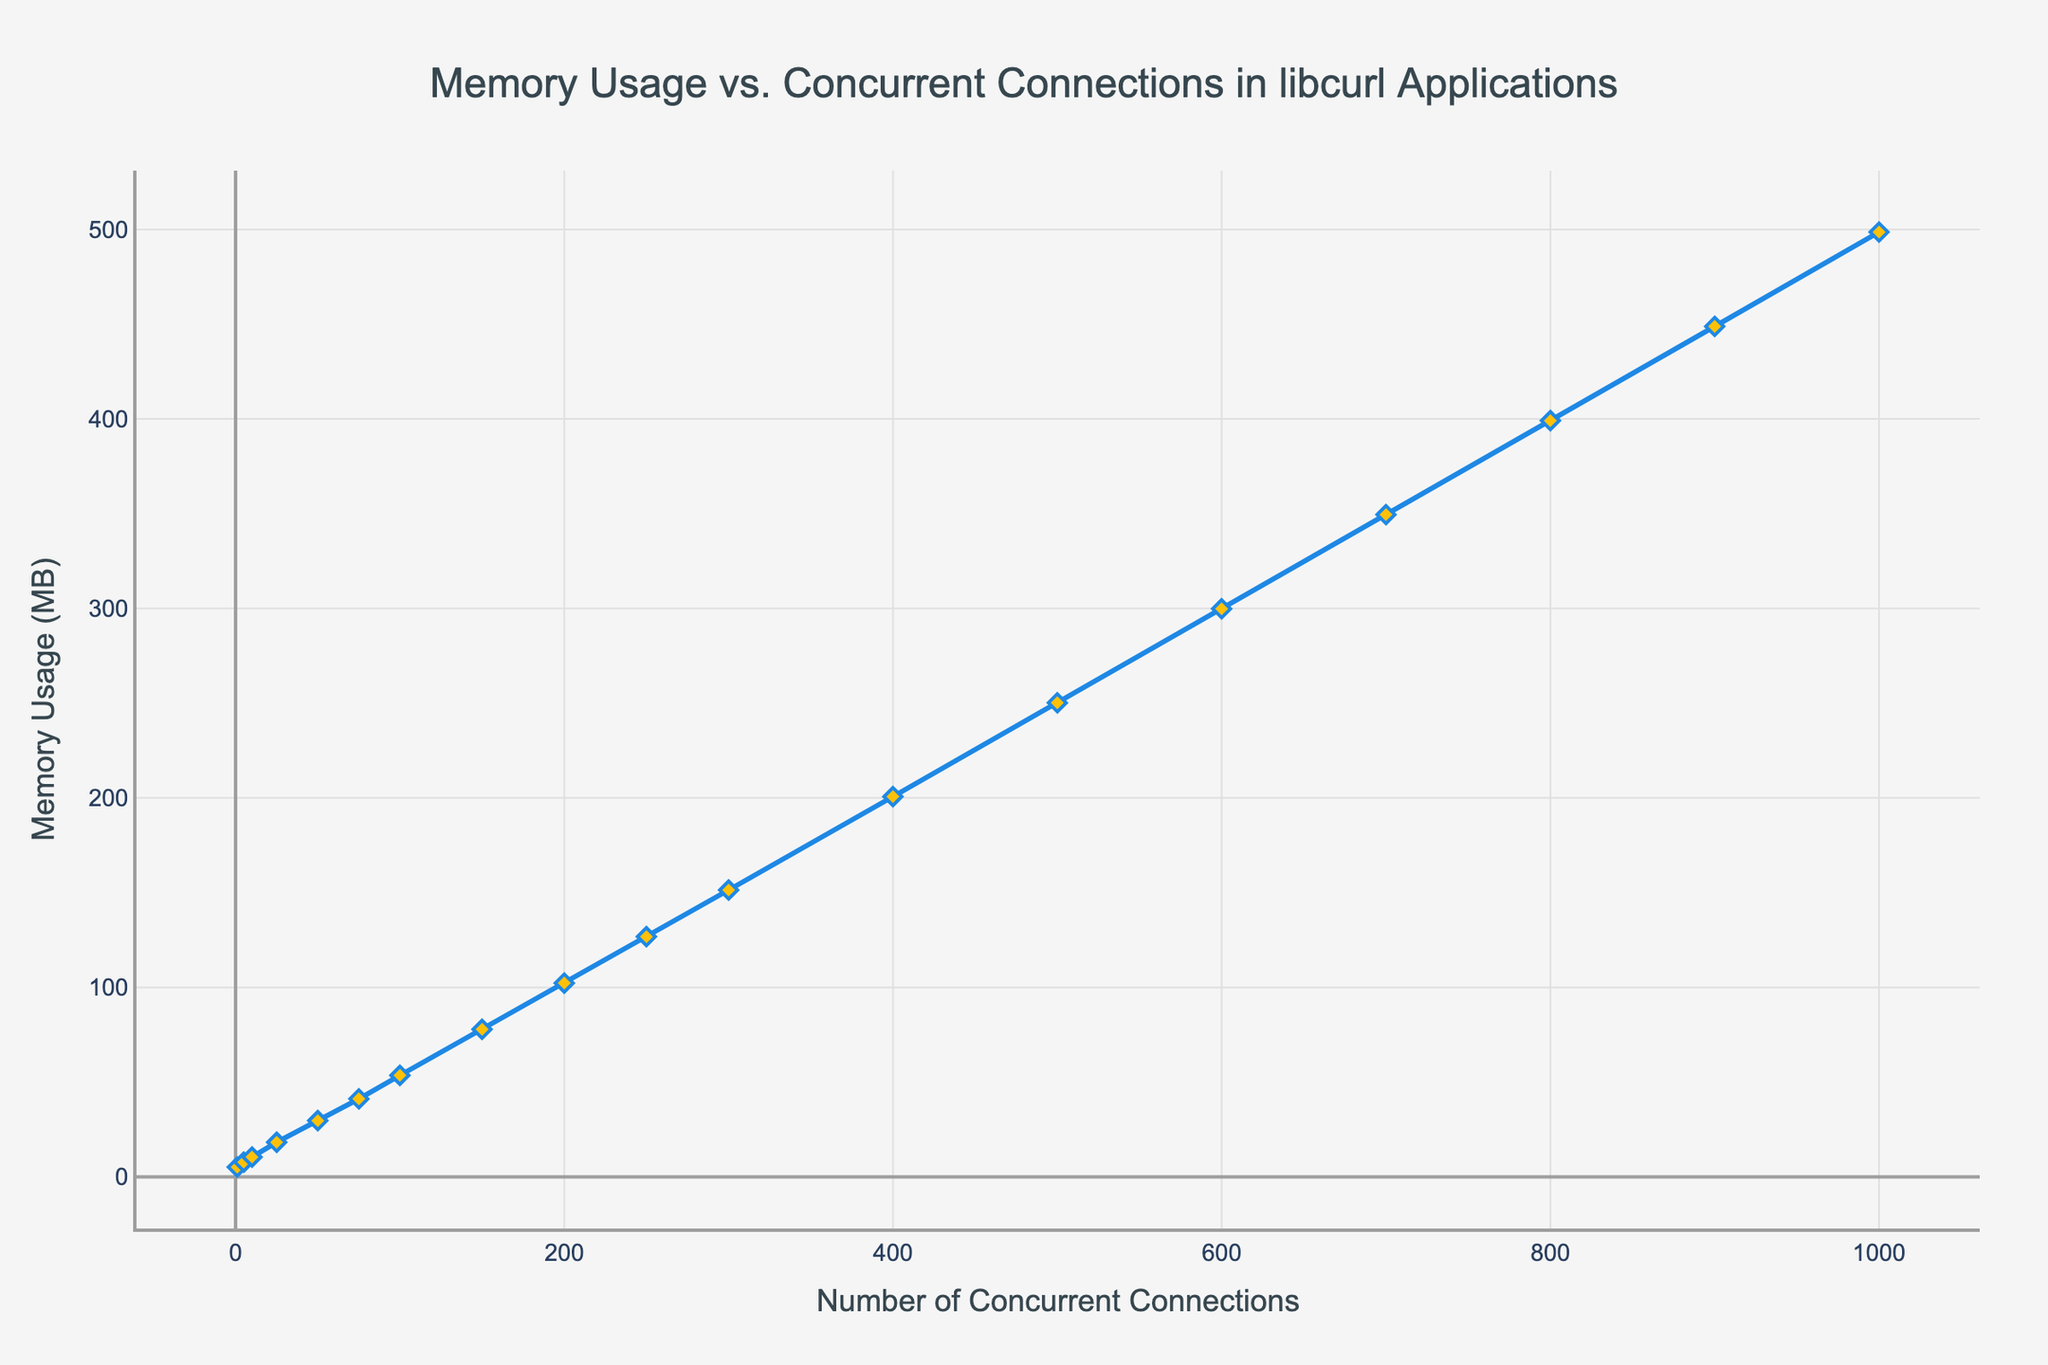What is the Memory Usage (MB) for 50 concurrent connections? Look for the data point where the number of concurrent connections is 50. The corresponding Memory Usage (MB) is easily readable from the y-axis.
Answer: 29.7 MB How much more memory is used at 200 connections compared to 100 connections? Subtract the Memory Usage (MB) at 100 connections from the Memory Usage (MB) at 200 connections. 102.3 MB - 53.6 MB = 48.7 MB.
Answer: 48.7 MB At which concurrent connections does the memory usage cross 100 MB? Find the data point where the Memory Usage (MB) first exceeds 100 MB. This occurs at 200 concurrent connections.
Answer: 200 connections What is the average Memory Usage (MB) for 1, 10, 100, and 1000 concurrent connections? Sum the Memory Usage (MB) values for the given connection counts and divide by the number of connection counts. (5.2 + 10.5 + 53.6 + 498.6)/4 = 567.9/4 = 141.975 MB.
Answer: 141.975 MB Which range of concurrent connections sees the fastest increase in memory usage? Compare the differences in Memory Usage (MB) across different ranges. The increase is steepest between 1 to 100 connections, but the fastest rate of increase is between 200 and 400 connections.
Answer: 200 to 400 connections Is the memory usage trend linear as the number of connections increases? Observe the slope of the line; a non-linear trend would show a curve, while a linear trend would be a straight line. The plot shows a non-linear trend with increasing steepness as connections increase.
Answer: Non-linear What is the difference in memory usage between 300 and 500 concurrent connections? Subtract the Memory Usage (MB) at 300 connections from the Memory Usage (MB) at 500 connections. 250.2 MB - 151.4 MB = 98.8 MB.
Answer: 98.8 MB What is the color of the line representing Memory Usage in the chart? Observe the color of the line in the chart. The line color in the chart is blue.
Answer: Blue 